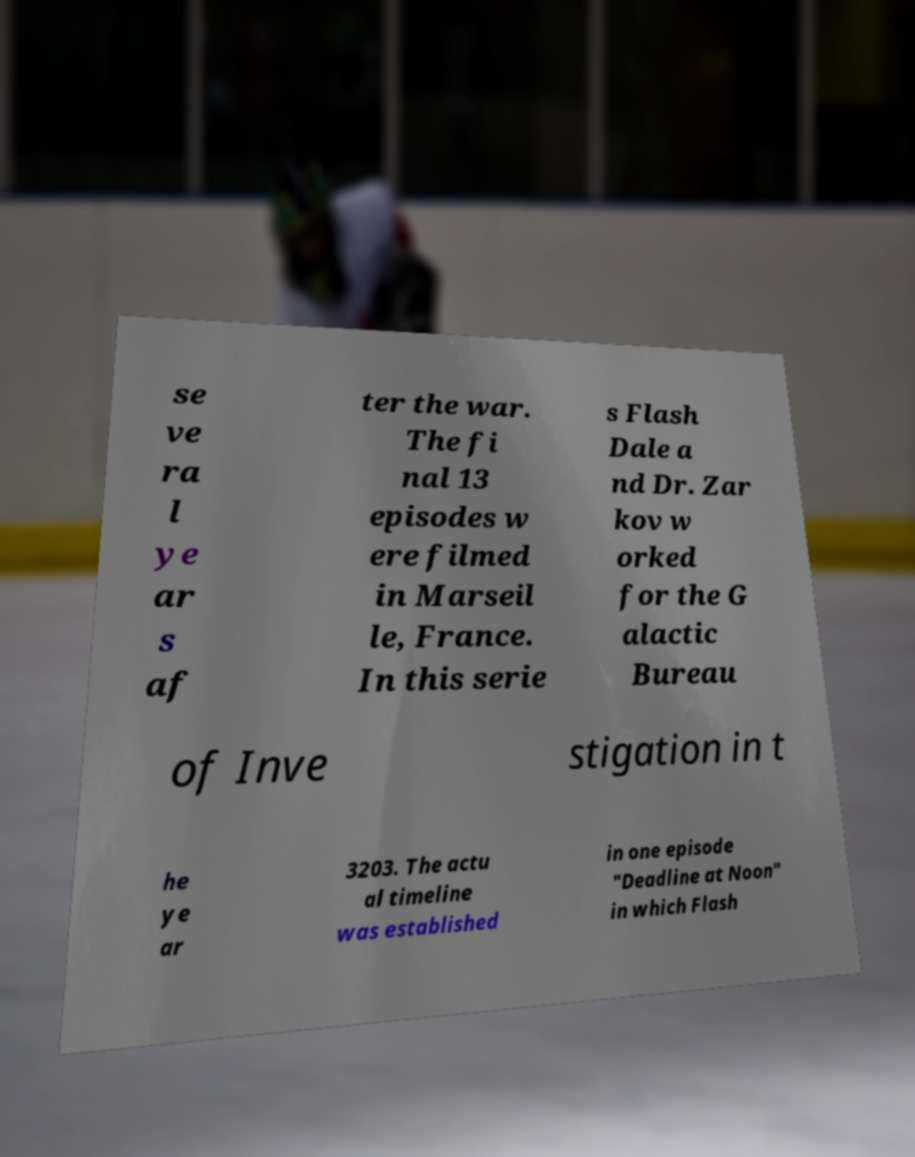Could you assist in decoding the text presented in this image and type it out clearly? se ve ra l ye ar s af ter the war. The fi nal 13 episodes w ere filmed in Marseil le, France. In this serie s Flash Dale a nd Dr. Zar kov w orked for the G alactic Bureau of Inve stigation in t he ye ar 3203. The actu al timeline was established in one episode "Deadline at Noon" in which Flash 